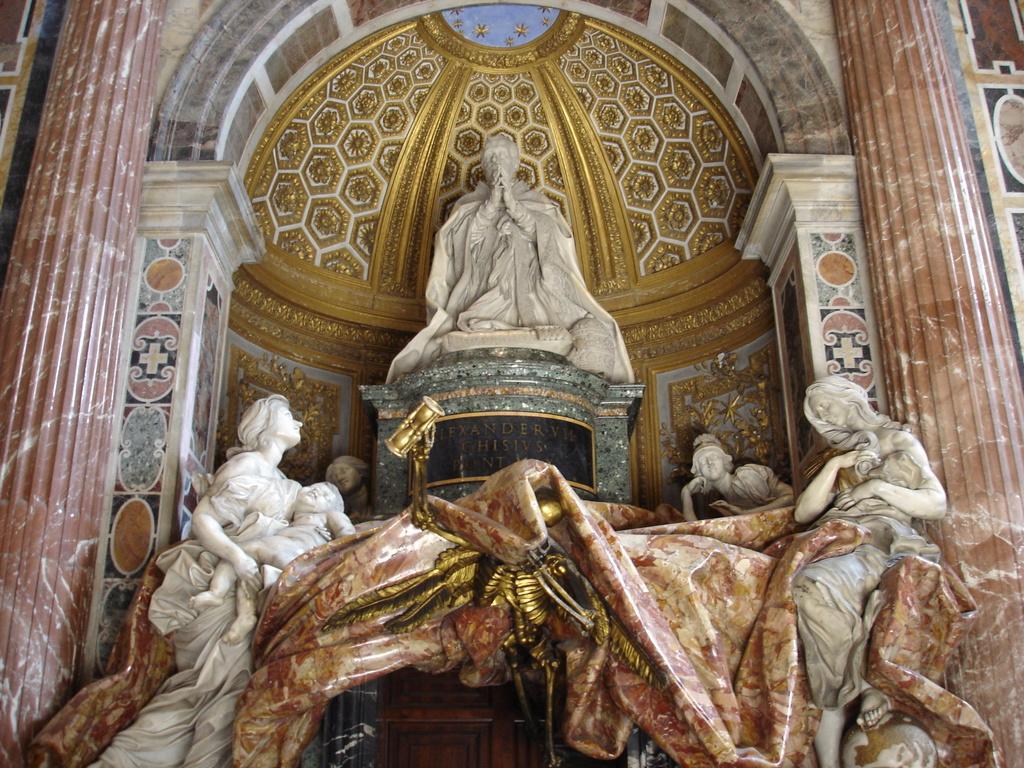Describe this image in one or two sentences. In this picture I can see statues and a cloth and I can see designer walls in the back. 